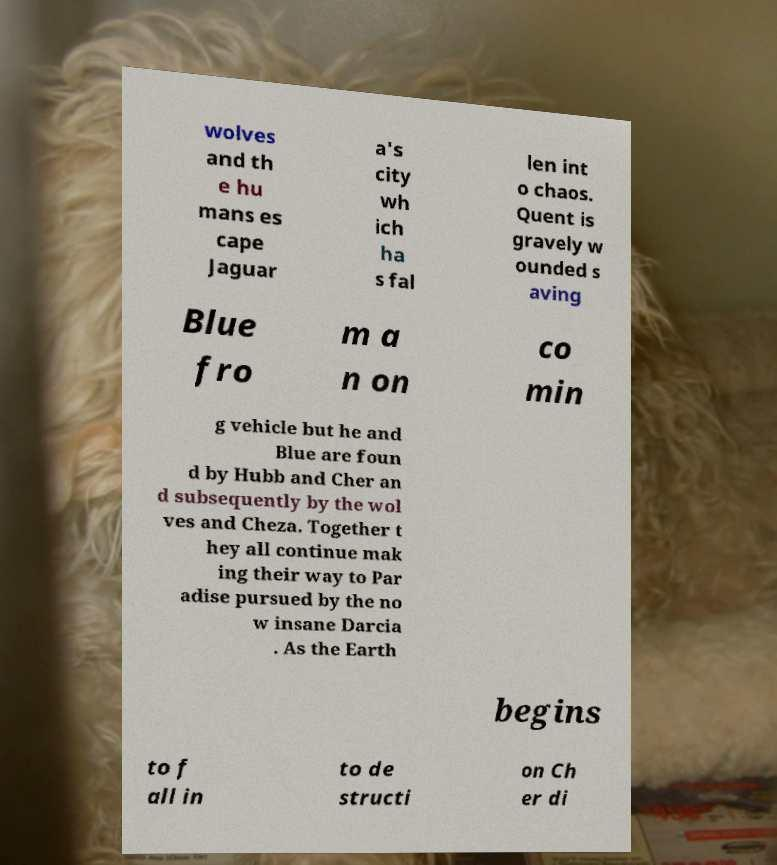What messages or text are displayed in this image? I need them in a readable, typed format. wolves and th e hu mans es cape Jaguar a's city wh ich ha s fal len int o chaos. Quent is gravely w ounded s aving Blue fro m a n on co min g vehicle but he and Blue are foun d by Hubb and Cher an d subsequently by the wol ves and Cheza. Together t hey all continue mak ing their way to Par adise pursued by the no w insane Darcia . As the Earth begins to f all in to de structi on Ch er di 